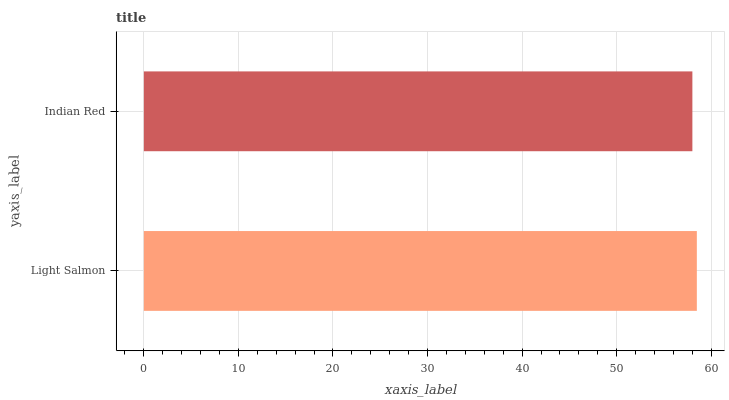Is Indian Red the minimum?
Answer yes or no. Yes. Is Light Salmon the maximum?
Answer yes or no. Yes. Is Indian Red the maximum?
Answer yes or no. No. Is Light Salmon greater than Indian Red?
Answer yes or no. Yes. Is Indian Red less than Light Salmon?
Answer yes or no. Yes. Is Indian Red greater than Light Salmon?
Answer yes or no. No. Is Light Salmon less than Indian Red?
Answer yes or no. No. Is Light Salmon the high median?
Answer yes or no. Yes. Is Indian Red the low median?
Answer yes or no. Yes. Is Indian Red the high median?
Answer yes or no. No. Is Light Salmon the low median?
Answer yes or no. No. 